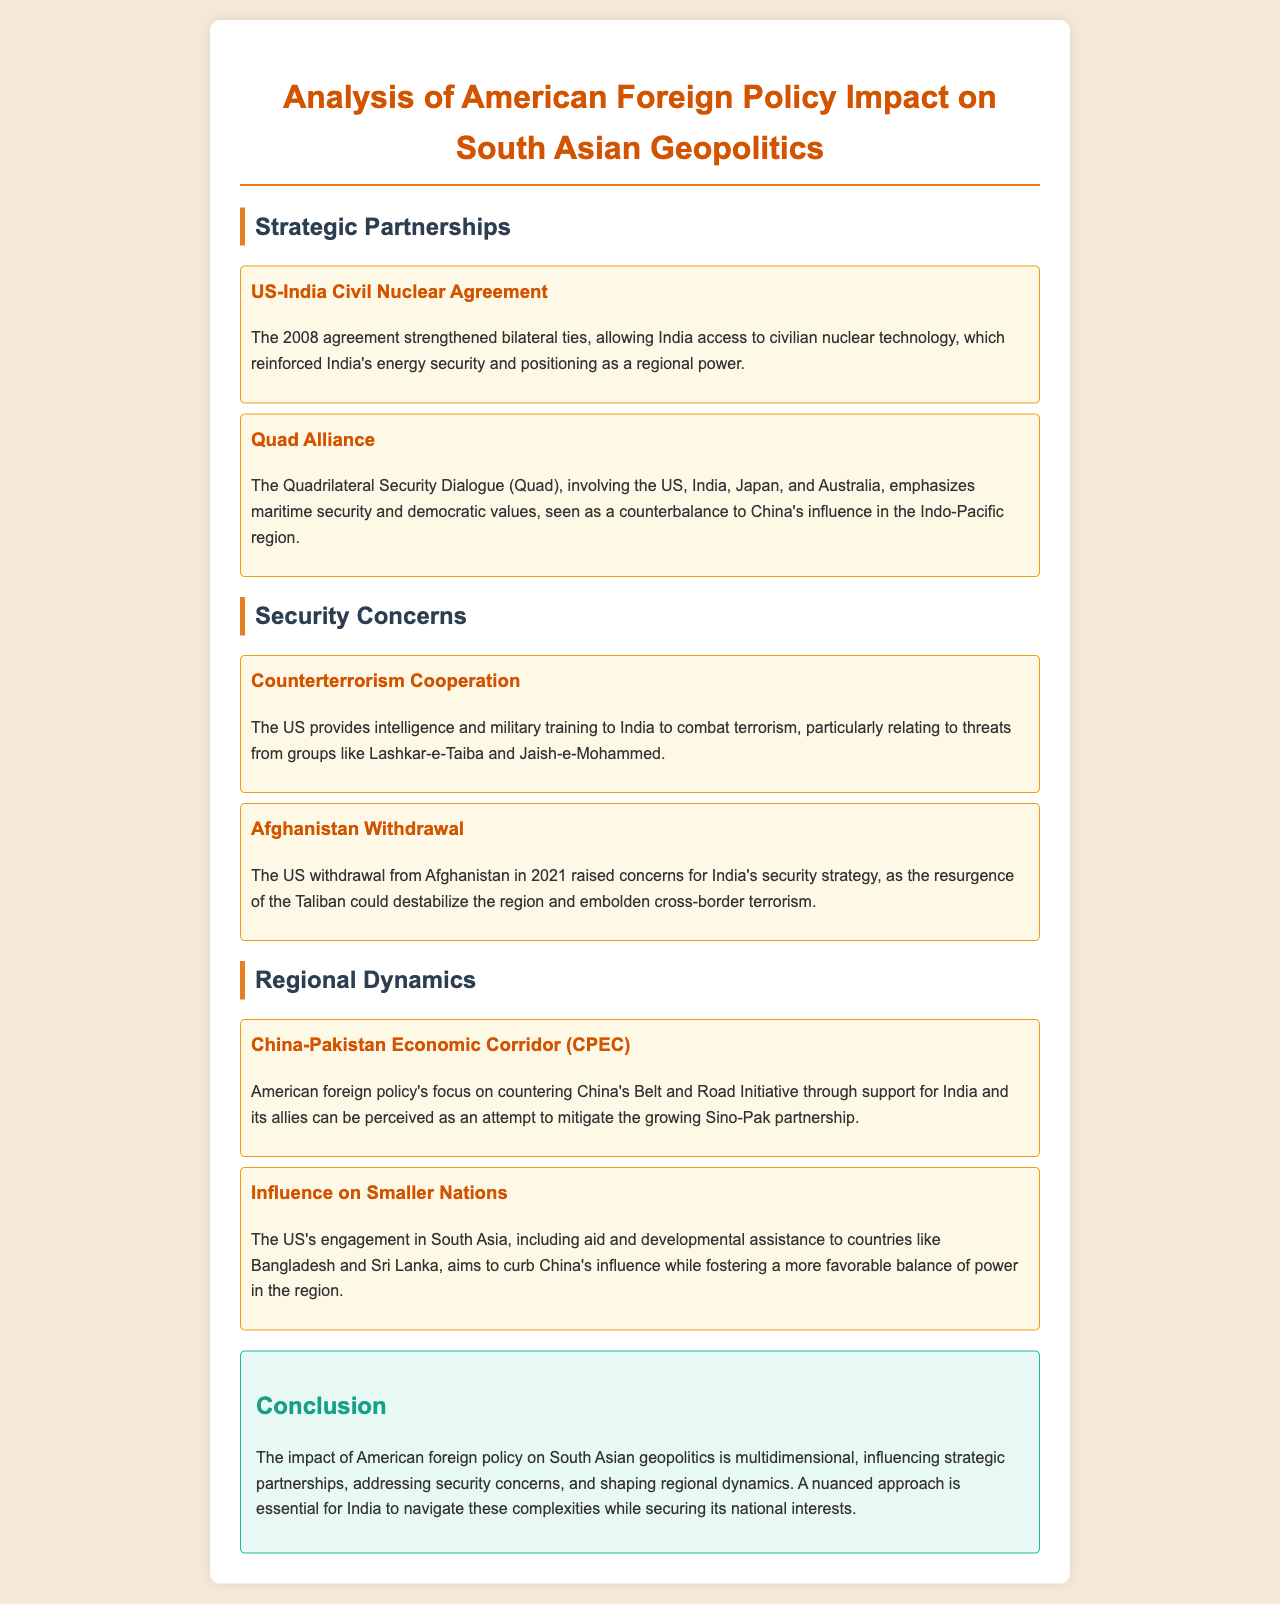what year was the US-India Civil Nuclear Agreement signed? The document mentions the year when the agreement was established, which is 2008.
Answer: 2008 what does the Quad Alliance emphasize? The Quad Alliance emphasizes maritime security and democratic values.
Answer: maritime security and democratic values which terrorist groups are mentioned regarding counterterrorism cooperation? The document identifies specific groups that pose a threat, namely Lashkar-e-Taiba and Jaish-e-Mohammed.
Answer: Lashkar-e-Taiba and Jaish-e-Mohammed what significant event in 2021 raised security concerns for India? The document discusses a major event that could affect regional stability, which is the US withdrawal from Afghanistan.
Answer: US withdrawal from Afghanistan how does US foreign policy aim to influence smaller nations in South Asia? The document explains that the US engages with smaller nations through aid and developmental assistance to curb China's influence.
Answer: aid and developmental assistance what is the primary concern regarding the China-Pakistan Economic Corridor? The document highlights an American strategy to counter the China-Pakistan partnership as a significant concern.
Answer: countering China's Belt and Road Initiative what is the conclusion about American foreign policy's impact on South Asia? The conclusion states that the impact of American foreign policy is multidimensional, affecting strategic partnerships and security.
Answer: multidimensional impact which countries are included in the Quad? The document lists the countries involved in the Quad, which are the US, India, Japan, and Australia.
Answer: US, India, Japan, and Australia 